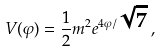<formula> <loc_0><loc_0><loc_500><loc_500>V ( \varphi ) = \frac { 1 } { 2 } m ^ { 2 } e ^ { 4 \varphi / \sqrt { 7 } } \, ,</formula> 